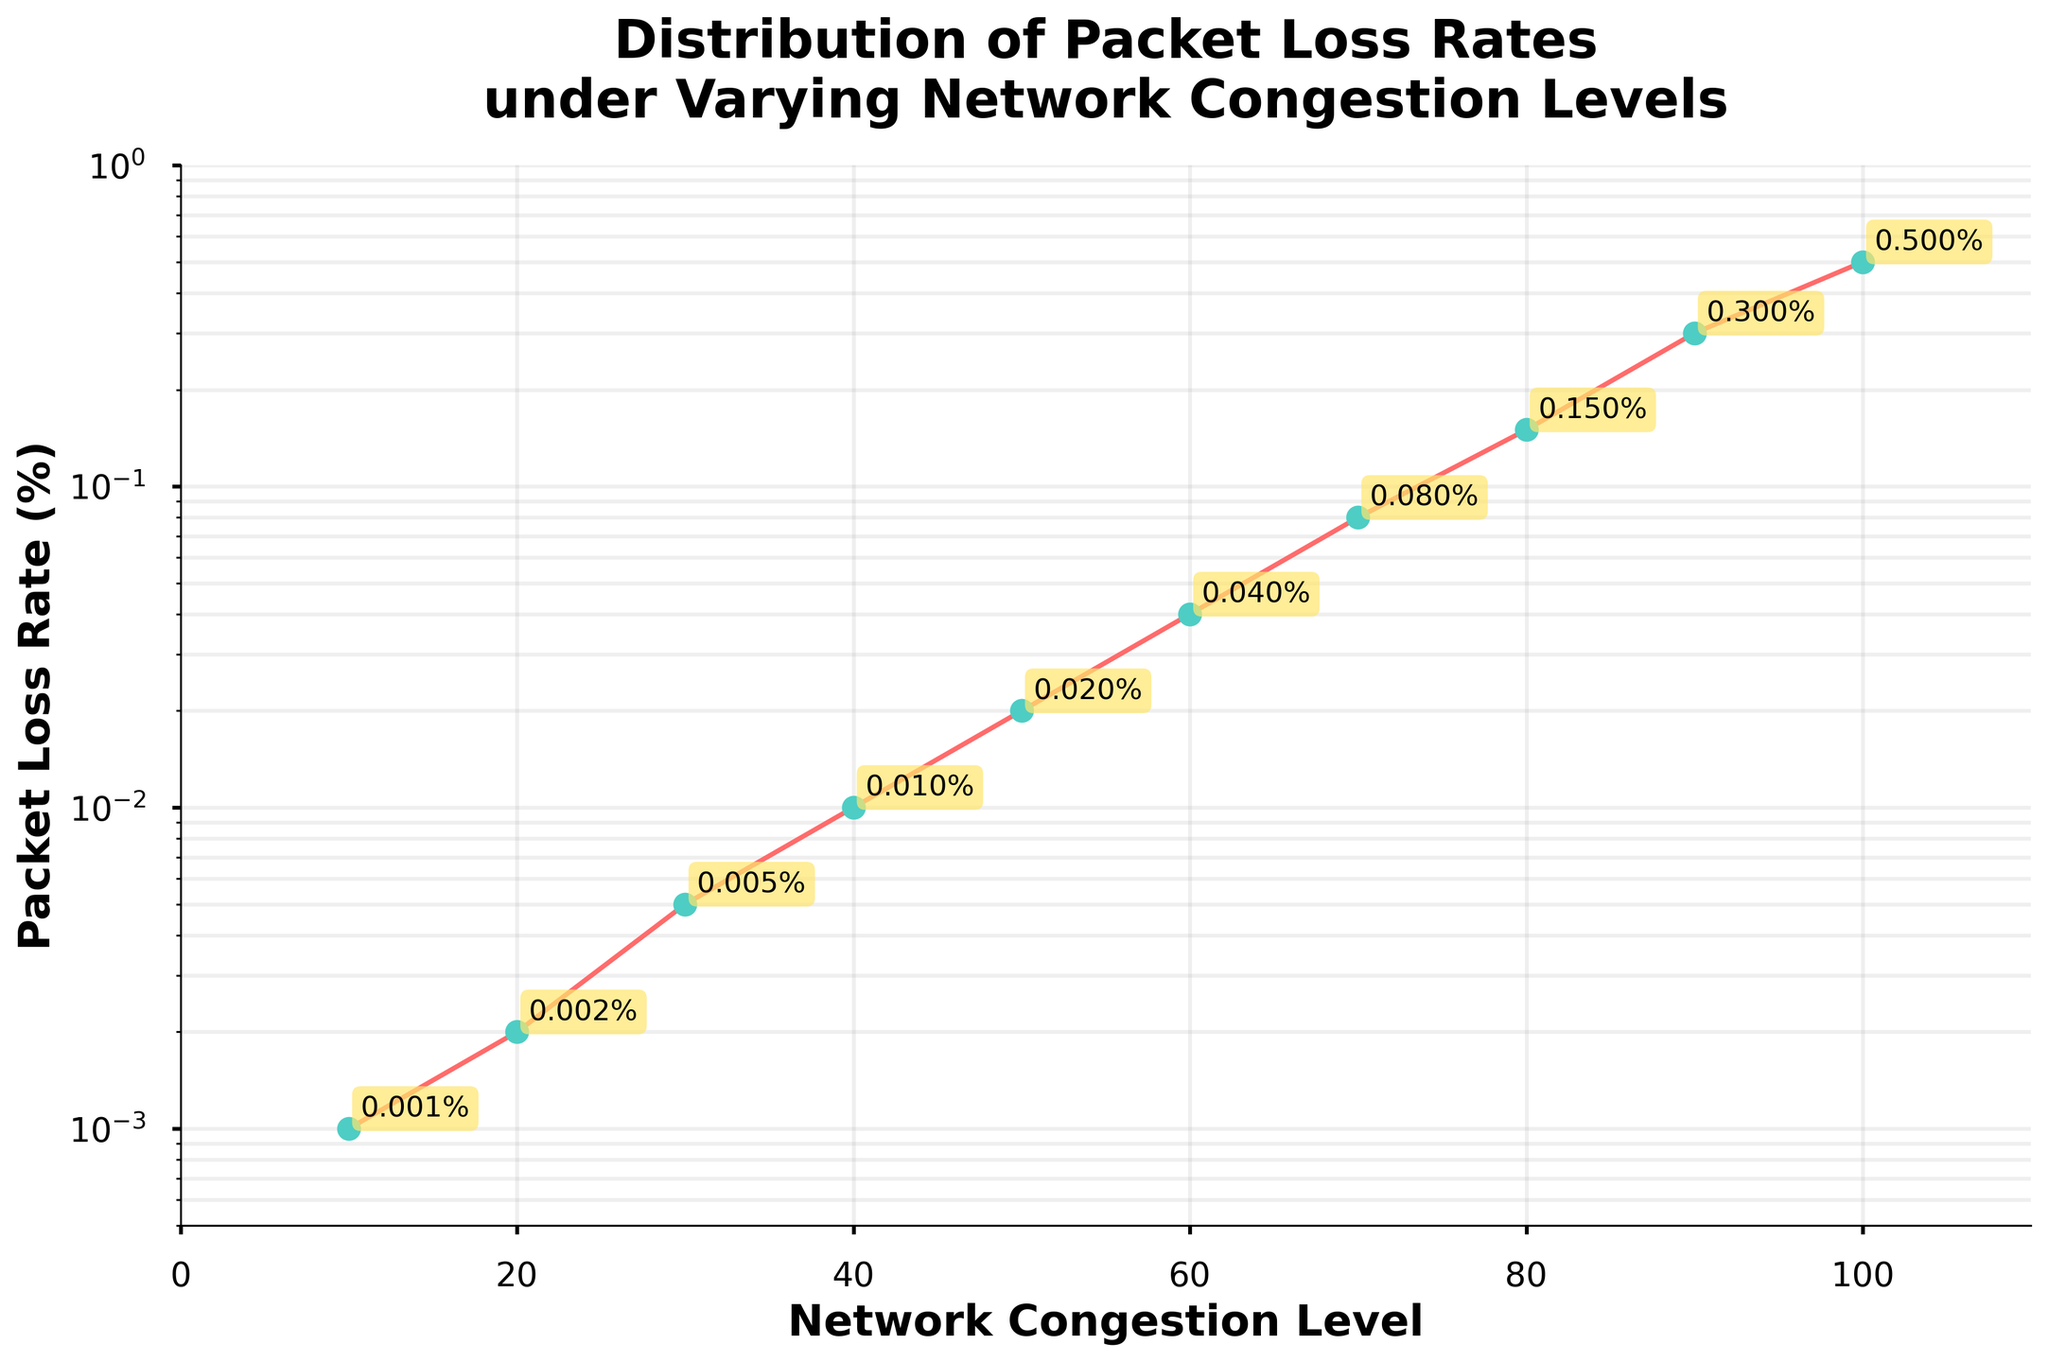What is the title of the figure? The title is displayed at the top of the figure in bold font. It reads: "Distribution of Packet Loss Rates under Varying Network Congestion Levels".
Answer: Distribution of Packet Loss Rates under Varying Network Congestion Levels How many data points are plotted on the figure? The number of data points can be identified by counting the markers on the line plot. There are markers at each network congestion level from 10 to 100.
Answer: 10 At which network congestion level does the packet loss rate reach 0.1%? To find this, we look at the y-axis for the value of 0.1%. Then check the x-axis to see where this value occurs. The packet loss rate of 0.1% occurs between the points corresponding to 40 and 50.
Answer: Between 40 and 50 What is the minimum packet loss rate recorded in the figure? The minimum packet loss rate can be identified by observing the lowest point on the y-axis. The lowest value plotted is 0.001%.
Answer: 0.001% What is the maximum packet loss rate recorded in the figure? The maximum packet loss rate is noted by looking at the highest point on the y-axis. The highest value plotted is 0.5%.
Answer: 0.5% Does the packet loss rate increase or decrease as network congestion level increases? Observing the trend of the line plot shows an upward movement as the network congestion level increases from 10 to 100, indicating an increase in packet loss rate.
Answer: Increases How does the packet loss rate change between a network congestion level of 30 and 70? To determine this, observe the packet loss rates at both levels. At 30, the rate is 0.005%, and at 70, it is 0.08%. The difference can be calculated.
Answer: Increases by 0.075% At what network congestion level does the packet loss rate start to exceed 0.1%? This can be determined by finding the point on the x-axis where the packet loss rate crosses the 0.1% mark. The plot shows this happens just past the 70% congestion level.
Answer: Just past 70% What is the average packet loss rate across all network congestion levels? Average packet loss rate is calculated by summing all packet loss rates and then dividing by the number of data points. Sum = 0.001 + 0.002 + 0.005 + 0.01 + 0.02 + 0.04 + 0.08 + 0.15 + 0.3 + 0.5 = 1.108. Average = 1.108 / 10 = 0.1108.
Answer: 0.1108% Which network congestion levels have a packet loss rate of less than 0.01%? Observing the y-values and corresponding x-values, the levels below 0.01% are at 10, 20, and 30.
Answer: 10, 20, 30% 